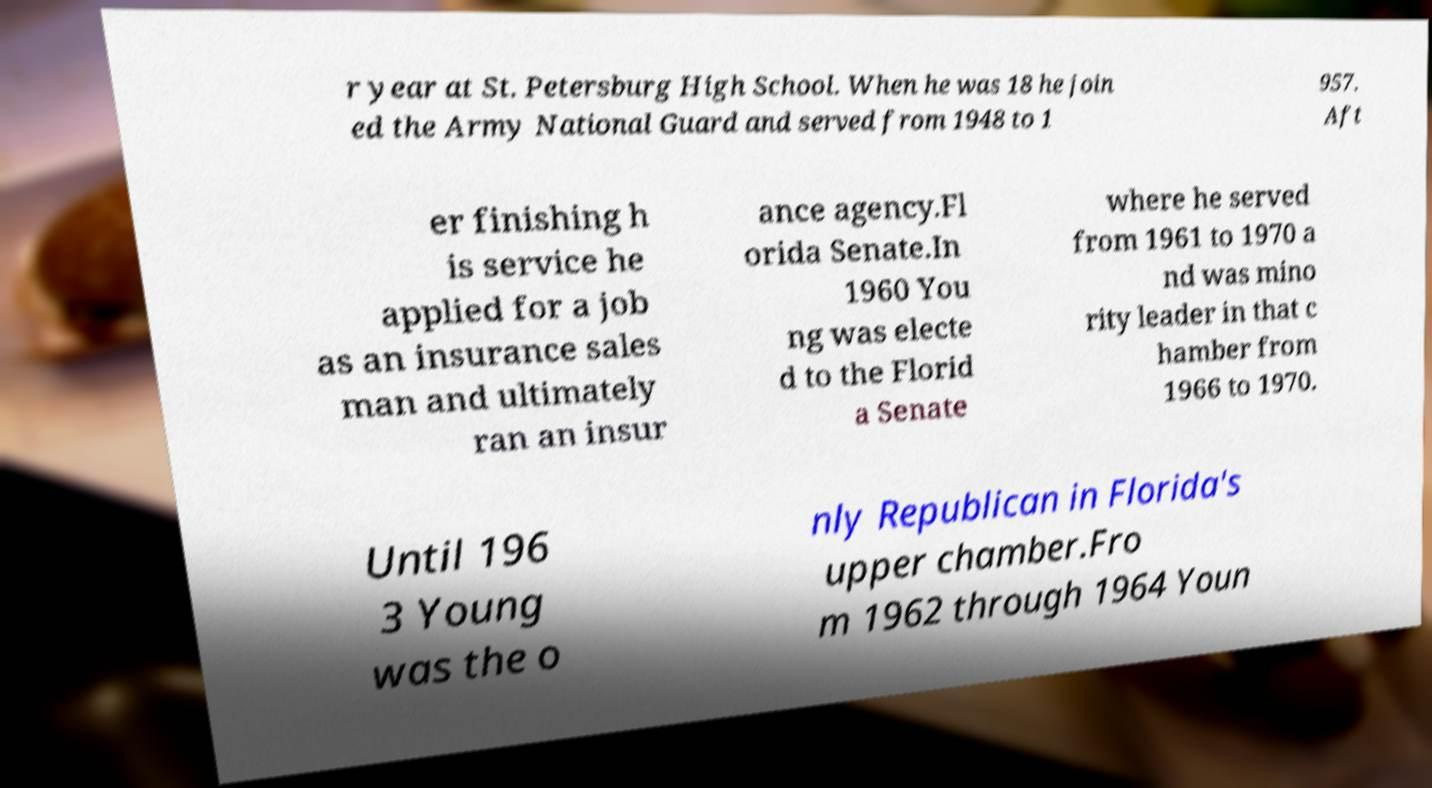Could you assist in decoding the text presented in this image and type it out clearly? r year at St. Petersburg High School. When he was 18 he join ed the Army National Guard and served from 1948 to 1 957. Aft er finishing h is service he applied for a job as an insurance sales man and ultimately ran an insur ance agency.Fl orida Senate.In 1960 You ng was electe d to the Florid a Senate where he served from 1961 to 1970 a nd was mino rity leader in that c hamber from 1966 to 1970. Until 196 3 Young was the o nly Republican in Florida's upper chamber.Fro m 1962 through 1964 Youn 